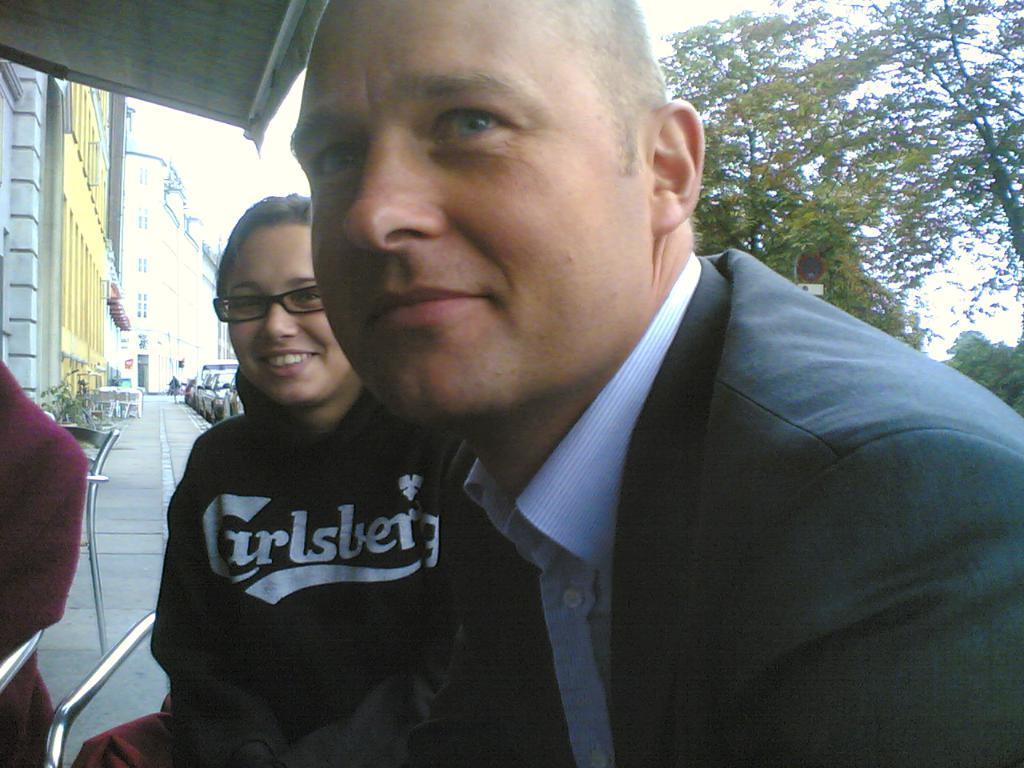Could you give a brief overview of what you see in this image? This image consists of three persons. In the front, we can see a man wearing a black suit. Beside him, there is a woman wearing a black jacket. In the background, there are trees and cars. On the left, there are many buildings. At the top, there is the sky. 